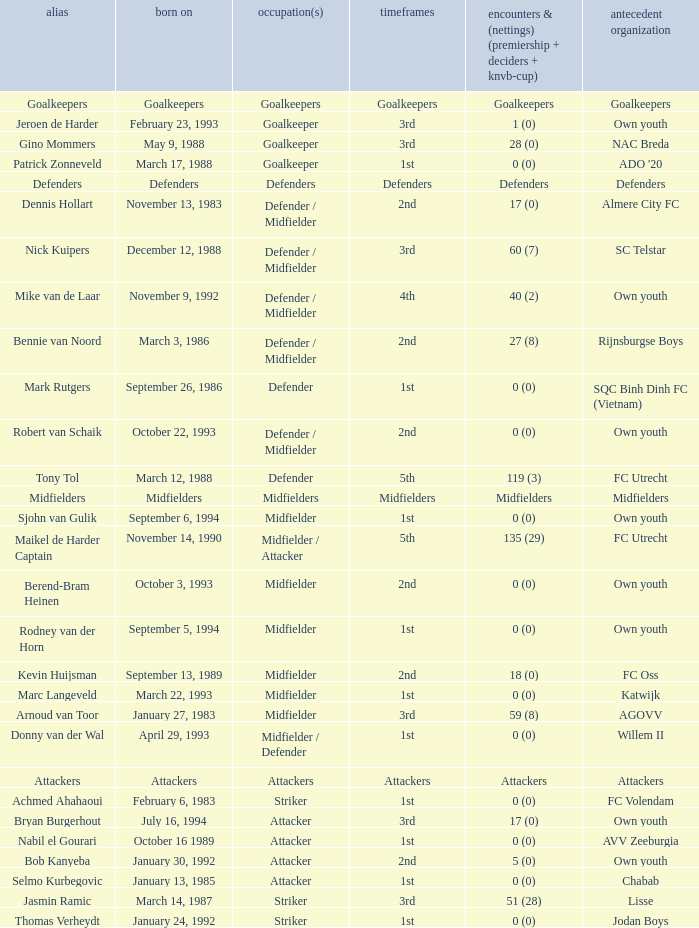What previous club was born on October 22, 1993? Own youth. 